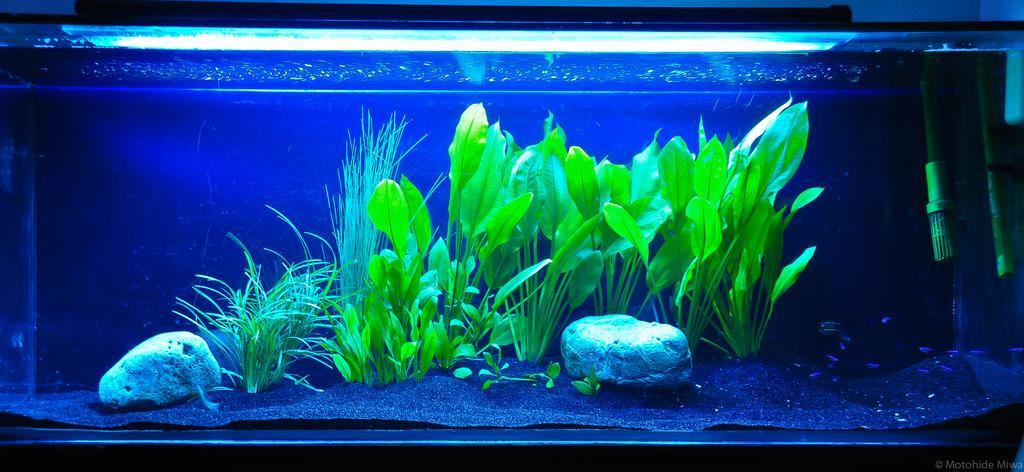Please provide a concise description of this image. In this image I can see an aquarium. In this aquarium I can see the grass, plants and the stones. I can also see the fish inside the aquarium. 